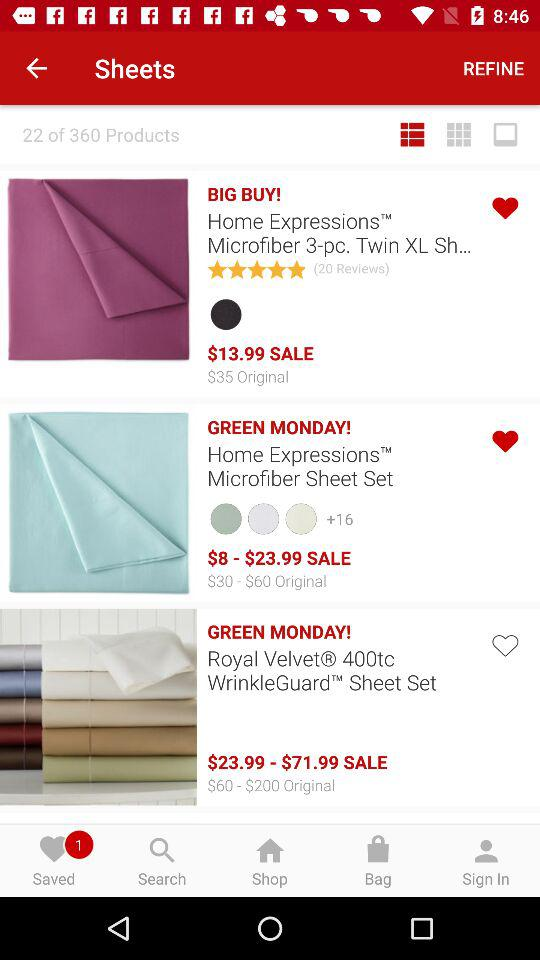What is the original price range of the Royal Velvet sheet set that is now on sale for $23.99 - $71.99? The original price range for the Royal Velvet 400tc WrinkleGuard Sheet Set before the sale was $60 to $200. 